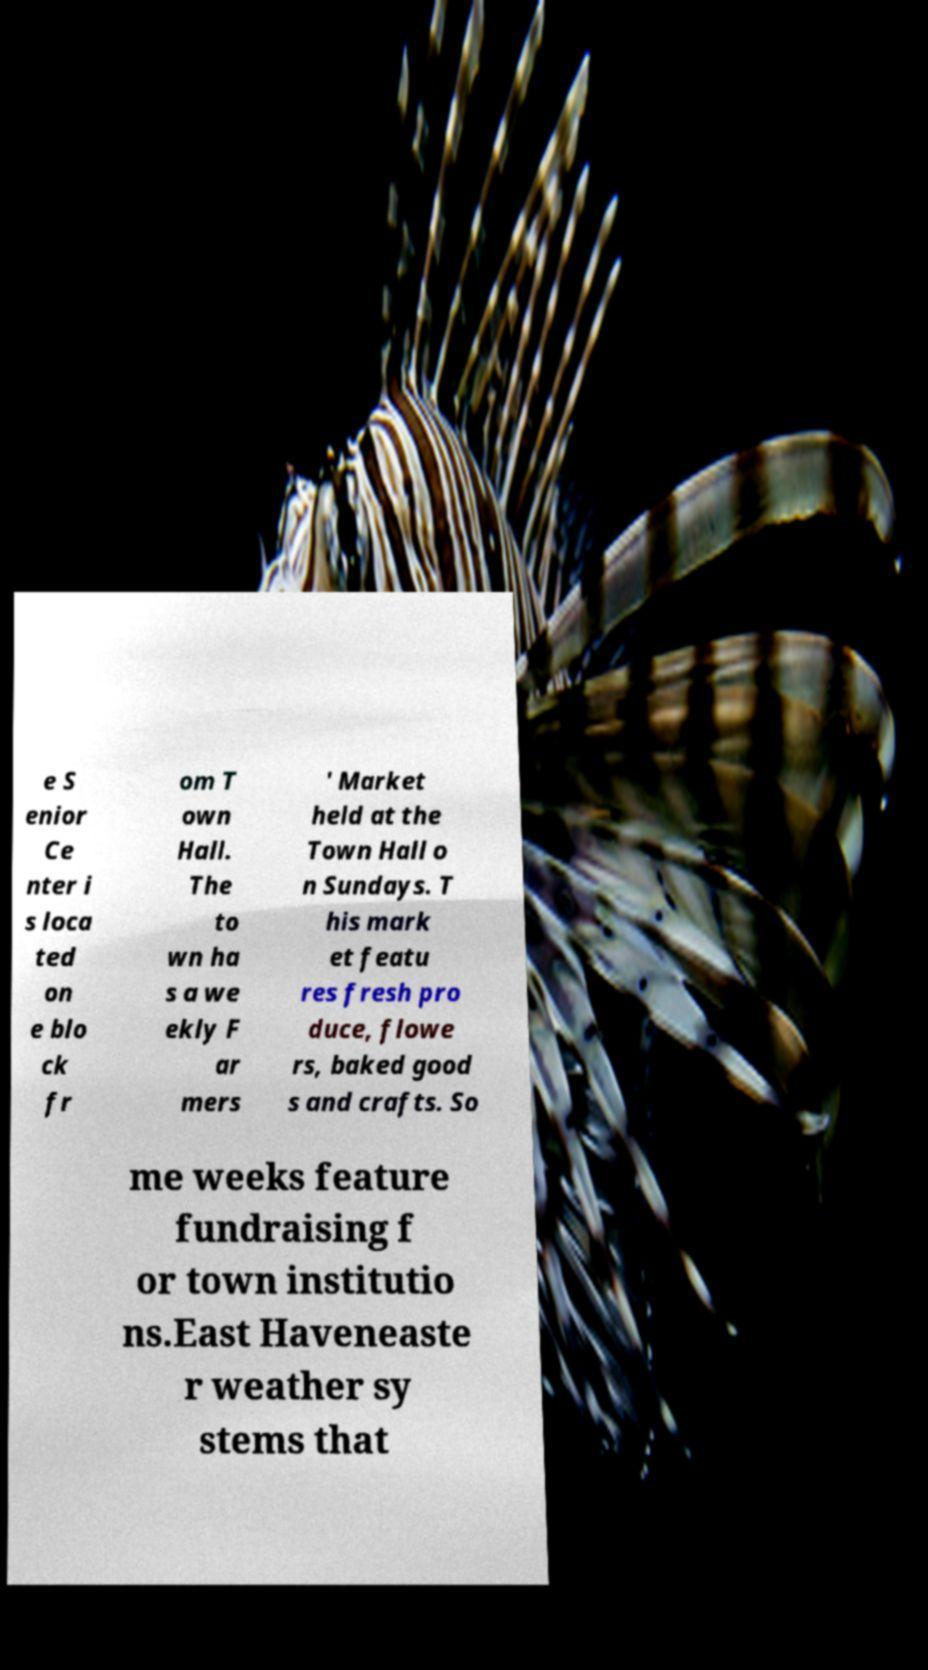Please read and relay the text visible in this image. What does it say? e S enior Ce nter i s loca ted on e blo ck fr om T own Hall. The to wn ha s a we ekly F ar mers ' Market held at the Town Hall o n Sundays. T his mark et featu res fresh pro duce, flowe rs, baked good s and crafts. So me weeks feature fundraising f or town institutio ns.East Haveneaste r weather sy stems that 